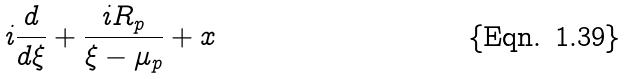Convert formula to latex. <formula><loc_0><loc_0><loc_500><loc_500>i \frac { d } { d \xi } + \frac { i R _ { p } } { \xi - \mu _ { p } } + x</formula> 